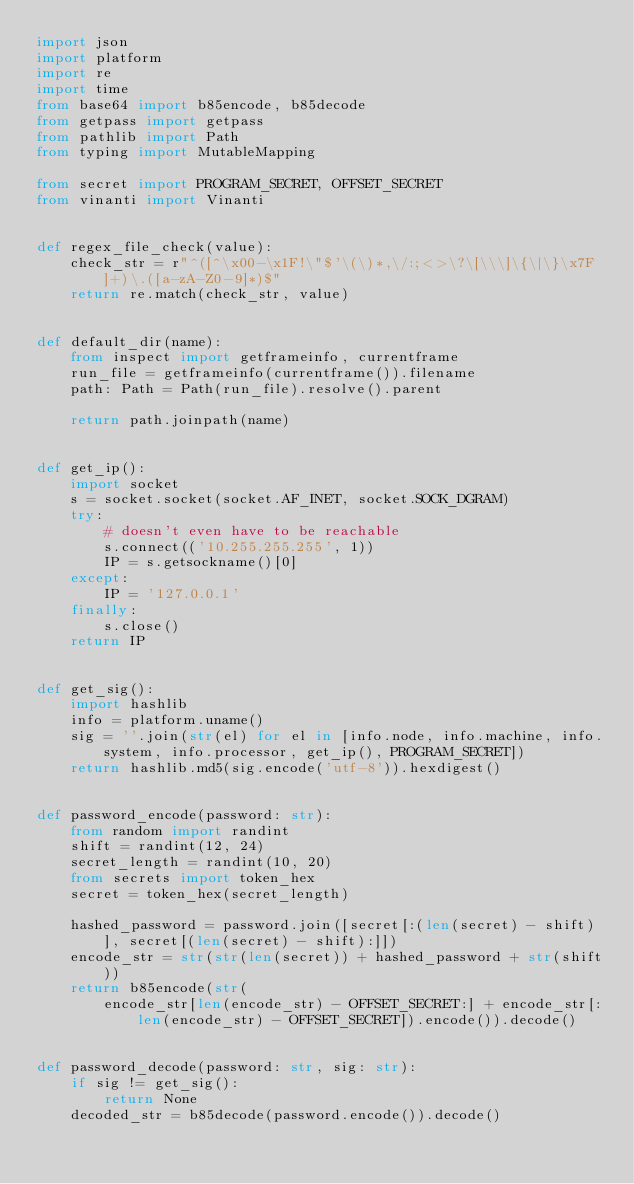Convert code to text. <code><loc_0><loc_0><loc_500><loc_500><_Python_>import json
import platform
import re
import time
from base64 import b85encode, b85decode
from getpass import getpass
from pathlib import Path
from typing import MutableMapping

from secret import PROGRAM_SECRET, OFFSET_SECRET
from vinanti import Vinanti


def regex_file_check(value):
    check_str = r"^([^\x00-\x1F!\"$'\(\)*,\/:;<>\?\[\\\]\{\|\}\x7F]+)\.([a-zA-Z0-9]*)$"
    return re.match(check_str, value)


def default_dir(name):
    from inspect import getframeinfo, currentframe
    run_file = getframeinfo(currentframe()).filename
    path: Path = Path(run_file).resolve().parent

    return path.joinpath(name)


def get_ip():
    import socket
    s = socket.socket(socket.AF_INET, socket.SOCK_DGRAM)
    try:
        # doesn't even have to be reachable
        s.connect(('10.255.255.255', 1))
        IP = s.getsockname()[0]
    except:
        IP = '127.0.0.1'
    finally:
        s.close()
    return IP


def get_sig():
    import hashlib
    info = platform.uname()
    sig = ''.join(str(el) for el in [info.node, info.machine, info.system, info.processor, get_ip(), PROGRAM_SECRET])
    return hashlib.md5(sig.encode('utf-8')).hexdigest()


def password_encode(password: str):
    from random import randint
    shift = randint(12, 24)
    secret_length = randint(10, 20)
    from secrets import token_hex
    secret = token_hex(secret_length)

    hashed_password = password.join([secret[:(len(secret) - shift)], secret[(len(secret) - shift):]])
    encode_str = str(str(len(secret)) + hashed_password + str(shift))
    return b85encode(str(
        encode_str[len(encode_str) - OFFSET_SECRET:] + encode_str[:len(encode_str) - OFFSET_SECRET]).encode()).decode()


def password_decode(password: str, sig: str):
    if sig != get_sig():
        return None
    decoded_str = b85decode(password.encode()).decode()</code> 